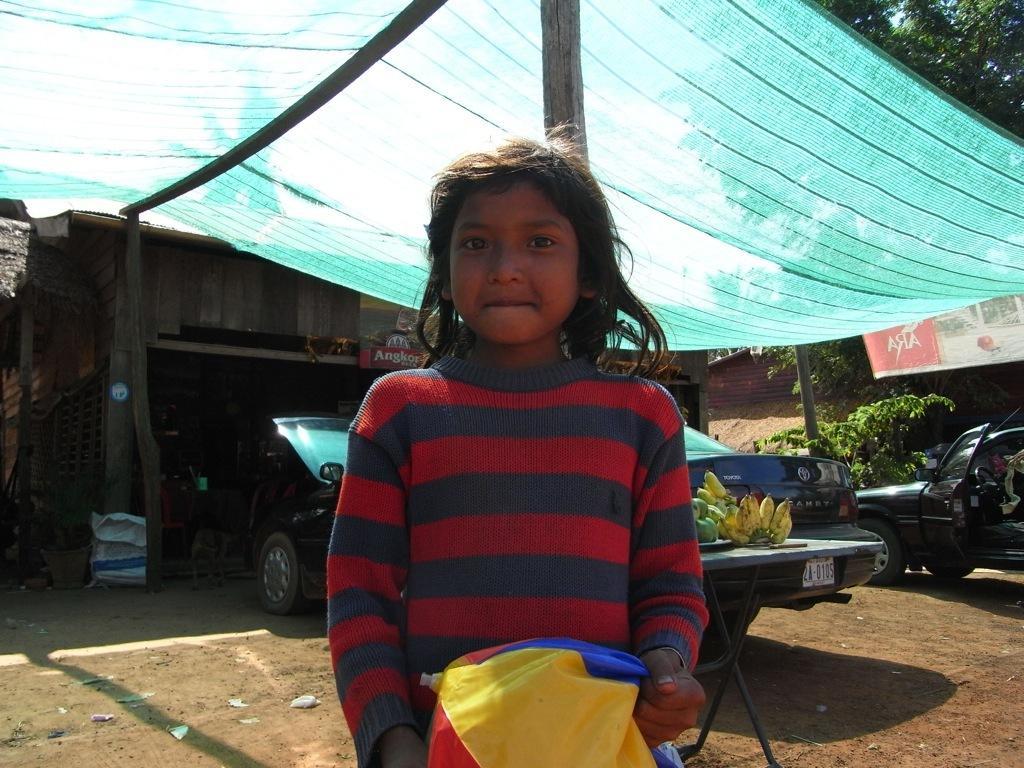In one or two sentences, can you explain what this image depicts? In the center of the image we can see a lady standing and holding a bag and there are lights. We can see bananas placed on the table. At the top there is a tent. In the background there is a shed and a tree. 